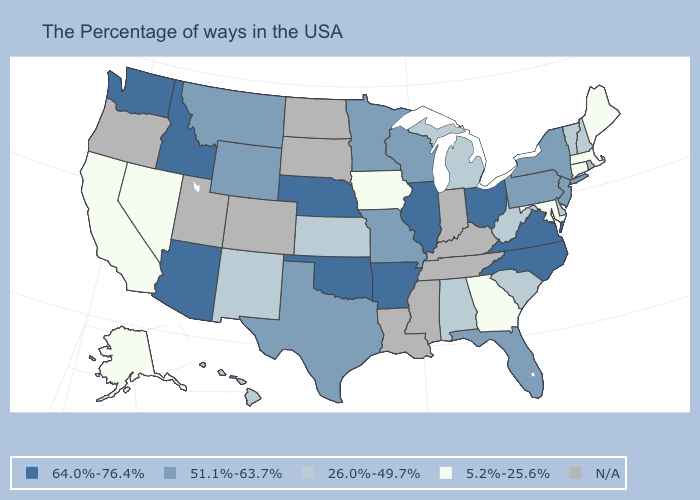Name the states that have a value in the range N/A?
Write a very short answer. Rhode Island, Kentucky, Indiana, Tennessee, Mississippi, Louisiana, South Dakota, North Dakota, Colorado, Utah, Oregon. What is the value of Nevada?
Write a very short answer. 5.2%-25.6%. Which states have the lowest value in the USA?
Answer briefly. Maine, Massachusetts, Connecticut, Maryland, Georgia, Iowa, Nevada, California, Alaska. Name the states that have a value in the range 51.1%-63.7%?
Quick response, please. New York, New Jersey, Pennsylvania, Florida, Wisconsin, Missouri, Minnesota, Texas, Wyoming, Montana. Among the states that border Nevada , which have the highest value?
Be succinct. Arizona, Idaho. What is the value of Nevada?
Concise answer only. 5.2%-25.6%. What is the lowest value in the South?
Give a very brief answer. 5.2%-25.6%. Name the states that have a value in the range 5.2%-25.6%?
Write a very short answer. Maine, Massachusetts, Connecticut, Maryland, Georgia, Iowa, Nevada, California, Alaska. Does the first symbol in the legend represent the smallest category?
Concise answer only. No. What is the value of Washington?
Short answer required. 64.0%-76.4%. Which states hav the highest value in the South?
Concise answer only. Virginia, North Carolina, Arkansas, Oklahoma. What is the highest value in the South ?
Give a very brief answer. 64.0%-76.4%. What is the lowest value in states that border Louisiana?
Quick response, please. 51.1%-63.7%. Name the states that have a value in the range 5.2%-25.6%?
Concise answer only. Maine, Massachusetts, Connecticut, Maryland, Georgia, Iowa, Nevada, California, Alaska. 